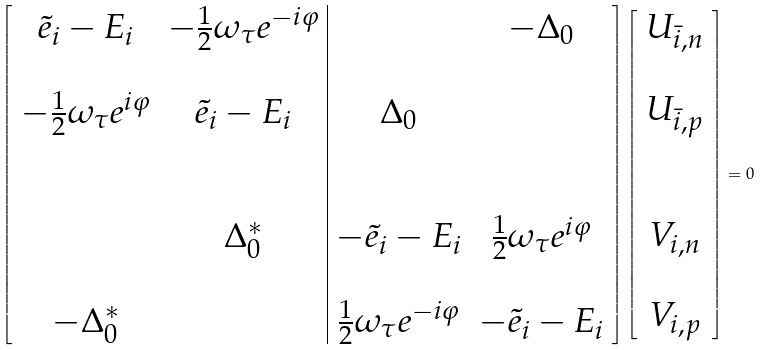<formula> <loc_0><loc_0><loc_500><loc_500>\left [ \begin{array} { c c | c c } \tilde { e } _ { i } - E _ { i } & - \frac { 1 } { 2 } \omega _ { \tau } e ^ { - i \varphi } & & - \Delta _ { 0 } \\ & & & \\ - \frac { 1 } { 2 } \omega _ { \tau } e ^ { i \varphi } & \tilde { e } _ { i } - E _ { i } & \Delta _ { 0 } & \\ & & & \\ & & & \\ & \Delta _ { 0 } ^ { \ast } & - \tilde { e } _ { i } - E _ { i } & \frac { 1 } { 2 } \omega _ { \tau } e ^ { i \varphi } \\ & & & \\ - \Delta _ { 0 } ^ { \ast } & & \frac { 1 } { 2 } \omega _ { \tau } e ^ { - i \varphi } & - \tilde { e } _ { i } - E _ { i } \end{array} \right ] \left [ \begin{array} { c } U _ { \bar { i } , n } \\ \\ U _ { \bar { i } , p } \\ \\ \\ V _ { i , n } \\ \\ V _ { i , p } \\ \end{array} \right ] = 0</formula> 